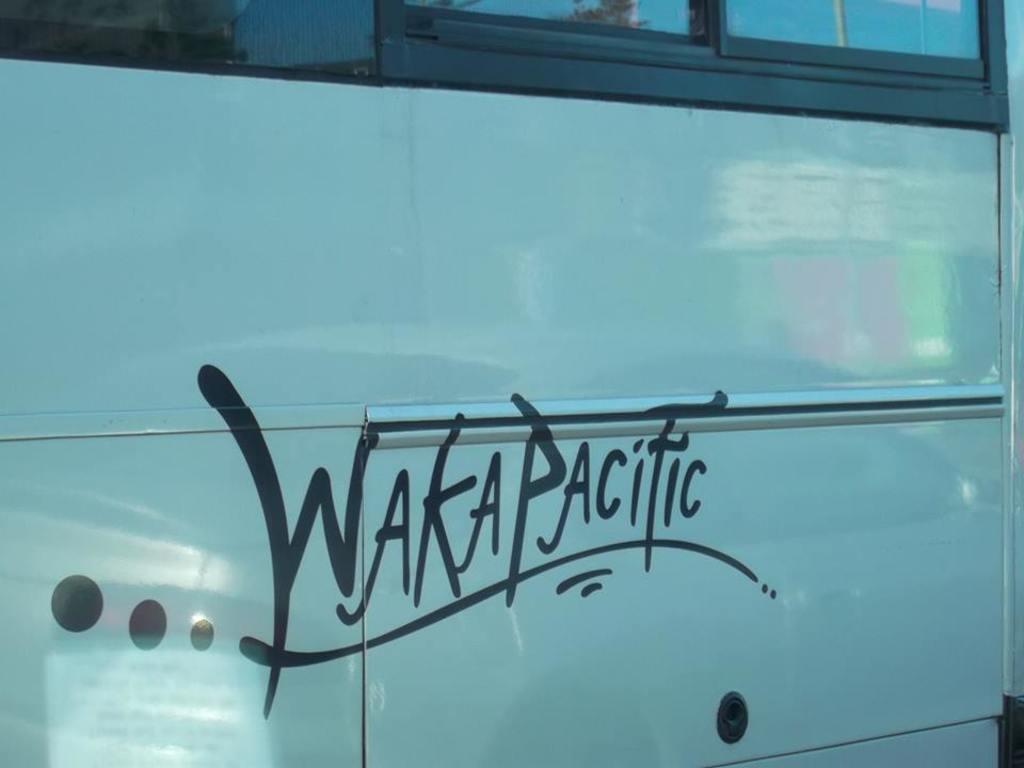What type of object is partially visible in the image? There is a part of a vehicle in the image. What features can be seen on the vehicle? The vehicle has windows. Is there any text or graphics on the vehicle? Yes, there is writing on the vehicle. Can you see a monkey building a nest on the vehicle in the image? There is no monkey or nest present in the image; it features a part of a vehicle with windows and writing. 